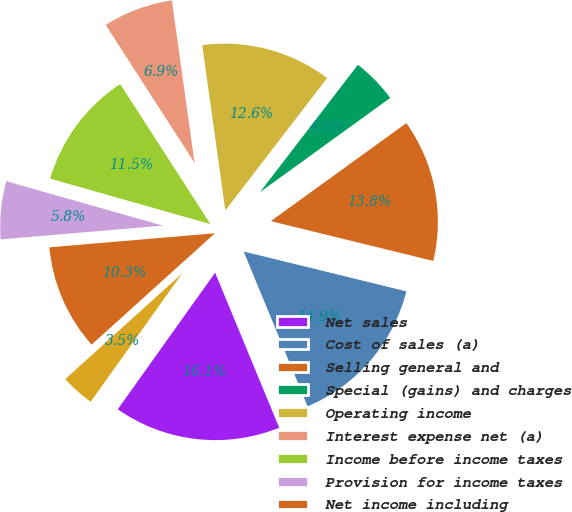Convert chart. <chart><loc_0><loc_0><loc_500><loc_500><pie_chart><fcel>Net sales<fcel>Cost of sales (a)<fcel>Selling general and<fcel>Special (gains) and charges<fcel>Operating income<fcel>Interest expense net (a)<fcel>Income before income taxes<fcel>Provision for income taxes<fcel>Net income including<fcel>Net income attributable to<nl><fcel>16.09%<fcel>14.94%<fcel>13.79%<fcel>4.6%<fcel>12.64%<fcel>6.9%<fcel>11.49%<fcel>5.75%<fcel>10.34%<fcel>3.45%<nl></chart> 